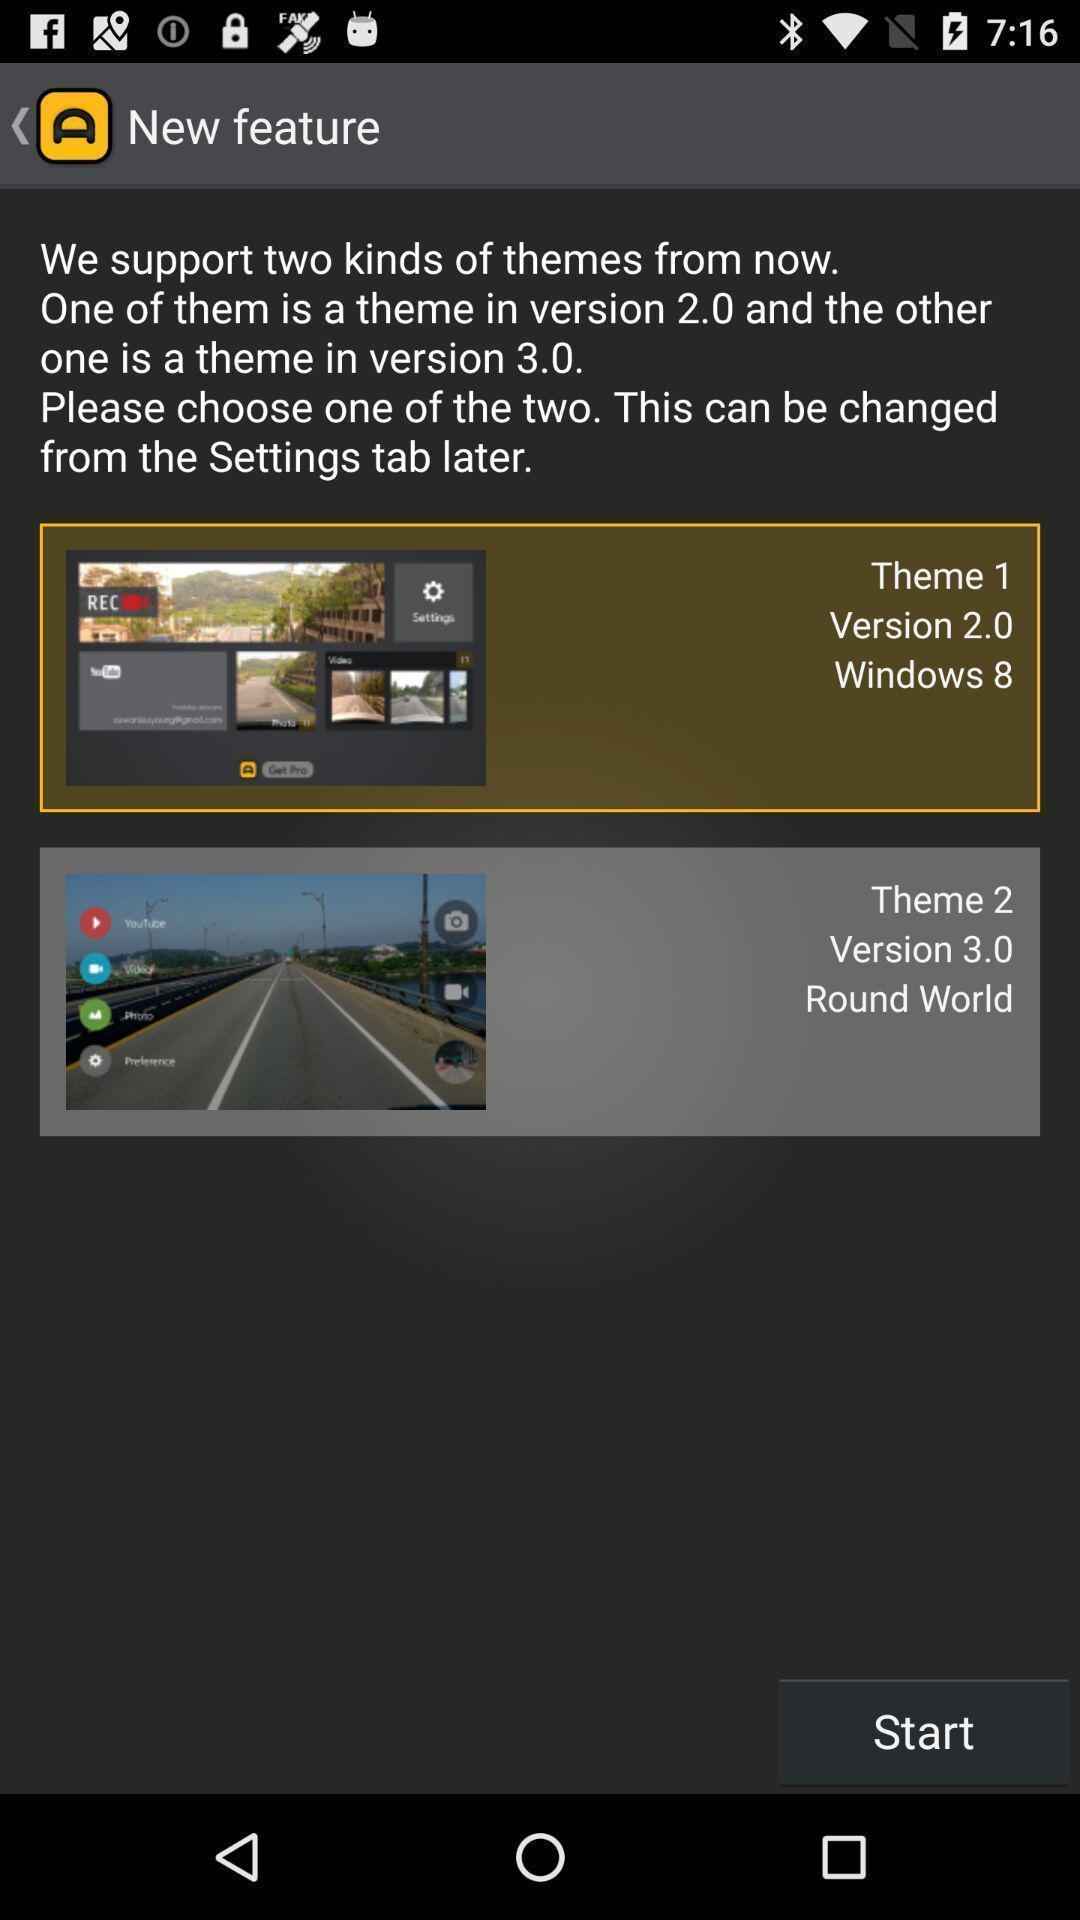Provide a detailed account of this screenshot. Start page. 